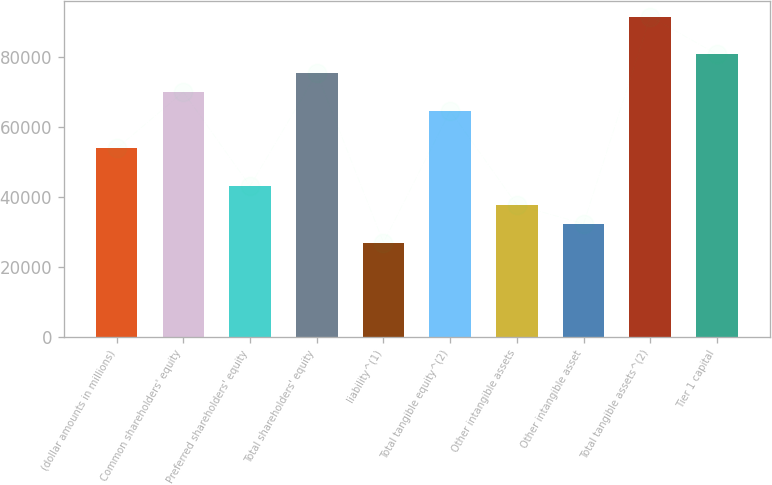Convert chart. <chart><loc_0><loc_0><loc_500><loc_500><bar_chart><fcel>(dollar amounts in millions)<fcel>Common shareholders' equity<fcel>Preferred shareholders' equity<fcel>Total shareholders' equity<fcel>liability^(1)<fcel>Total tangible equity^(2)<fcel>Other intangible assets<fcel>Other intangible asset<fcel>Total tangible assets^(2)<fcel>Tier 1 capital<nl><fcel>53893<fcel>70058.4<fcel>43116.1<fcel>75446.9<fcel>26950.7<fcel>64669.9<fcel>37727.6<fcel>32339.1<fcel>91612.3<fcel>80835.4<nl></chart> 